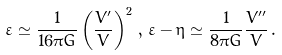<formula> <loc_0><loc_0><loc_500><loc_500>\varepsilon \simeq \frac { 1 } { 1 6 \pi G } \left ( \frac { V ^ { \prime } } { V } \right ) ^ { 2 } \, , \, \varepsilon - \eta \simeq \frac { 1 } { 8 \pi G } \frac { V ^ { \prime \prime } } { V } \, .</formula> 